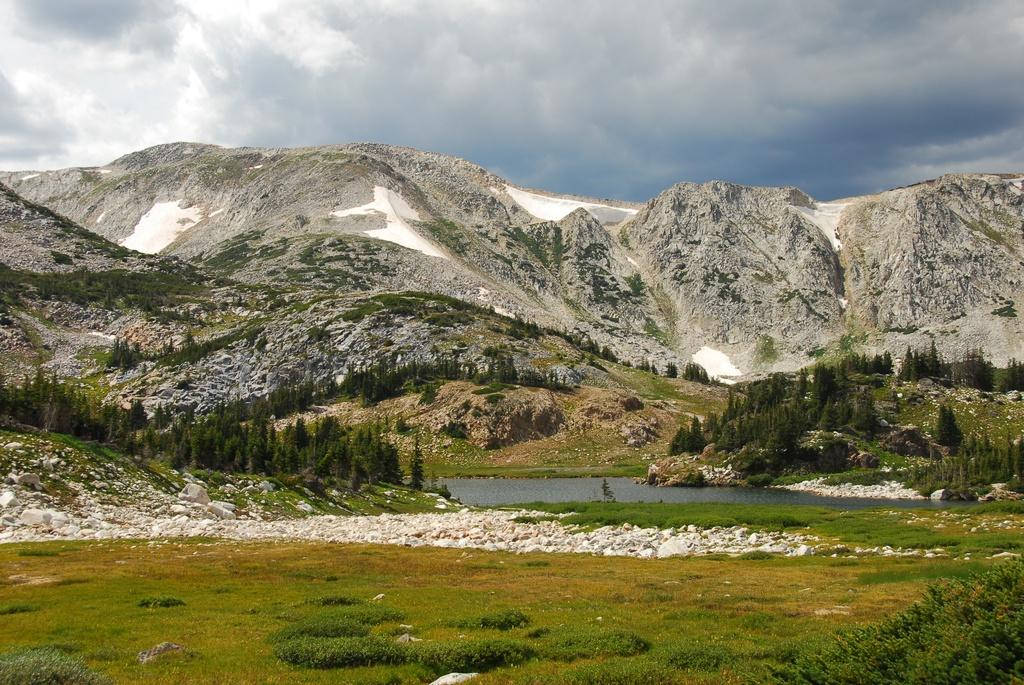What type of landform can be seen in the image? There is a hill in the image. What natural element is visible in the image? Water is visible in the image. What type of vegetation is present on the ground? Grass is present on the ground. What other types of vegetation can be seen in the image? There are plants and trees present in the image. How would you describe the sky in the image? The sky is cloudy in the image. Who is the expert in the image? There is no expert present in the image. What day is it in the image? The image does not depict a specific day, so it cannot be determined from the image. 